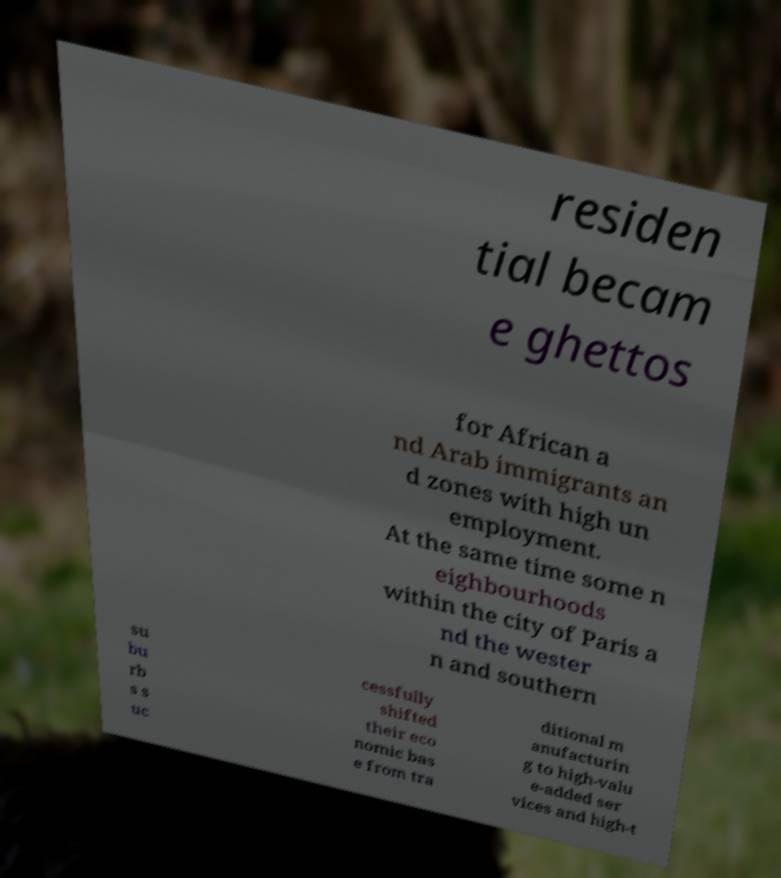Can you accurately transcribe the text from the provided image for me? residen tial becam e ghettos for African a nd Arab immigrants an d zones with high un employment. At the same time some n eighbourhoods within the city of Paris a nd the wester n and southern su bu rb s s uc cessfully shifted their eco nomic bas e from tra ditional m anufacturin g to high-valu e-added ser vices and high-t 